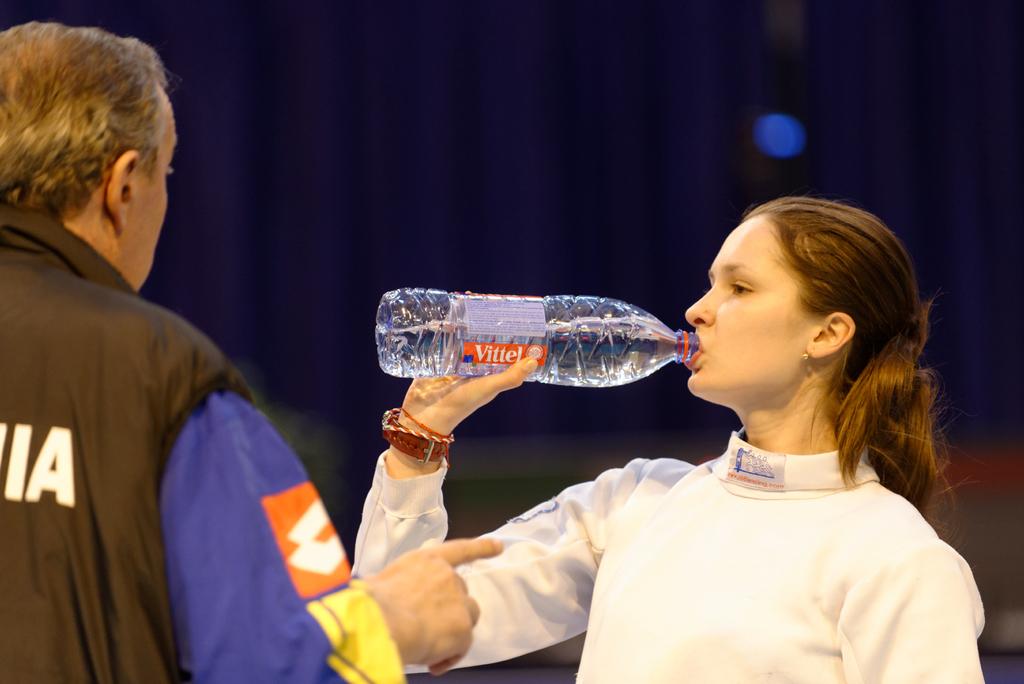What kind of water is she drinking?
Provide a succinct answer. Vittel. 